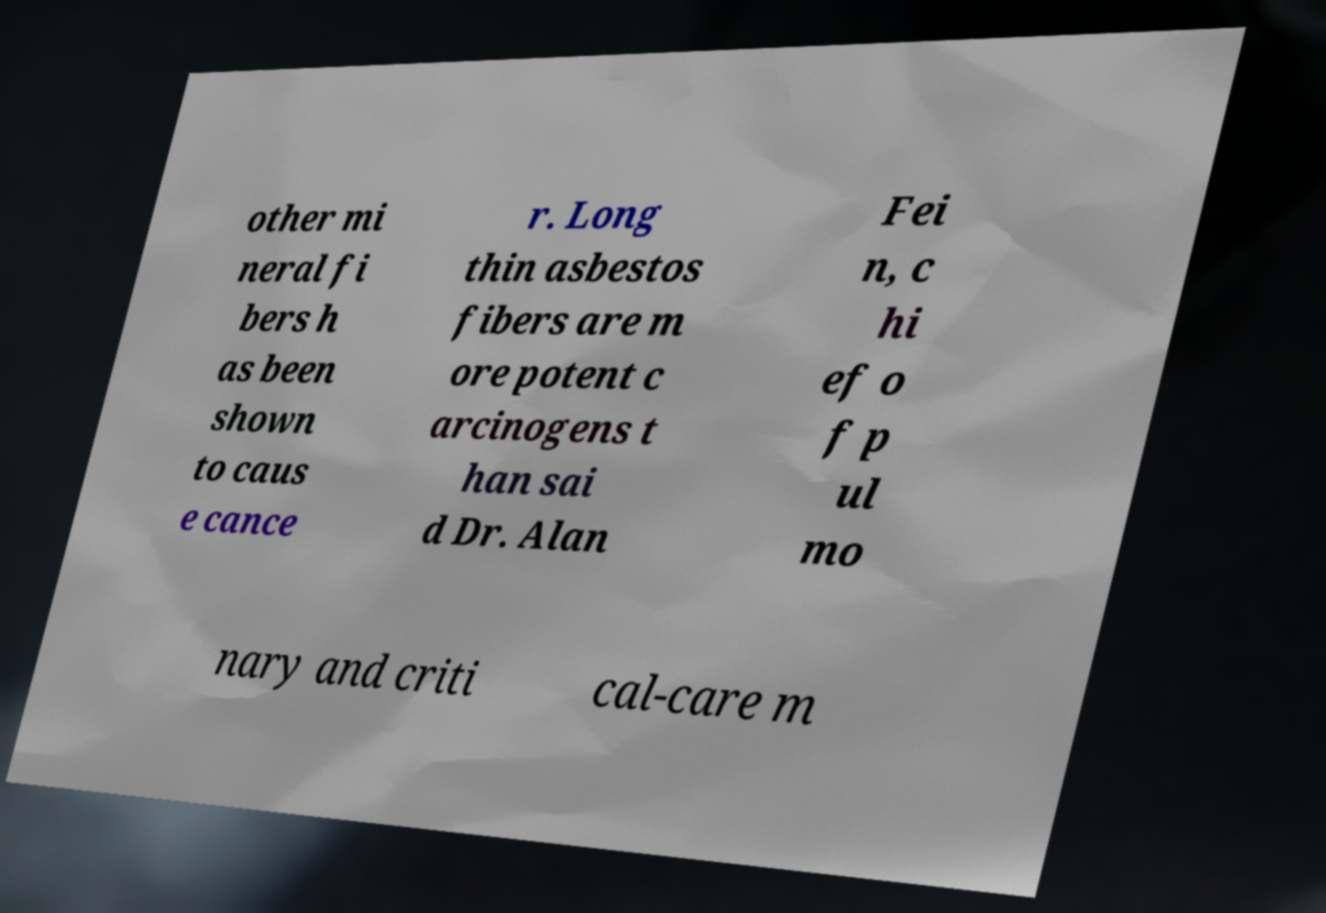Could you extract and type out the text from this image? other mi neral fi bers h as been shown to caus e cance r. Long thin asbestos fibers are m ore potent c arcinogens t han sai d Dr. Alan Fei n, c hi ef o f p ul mo nary and criti cal-care m 